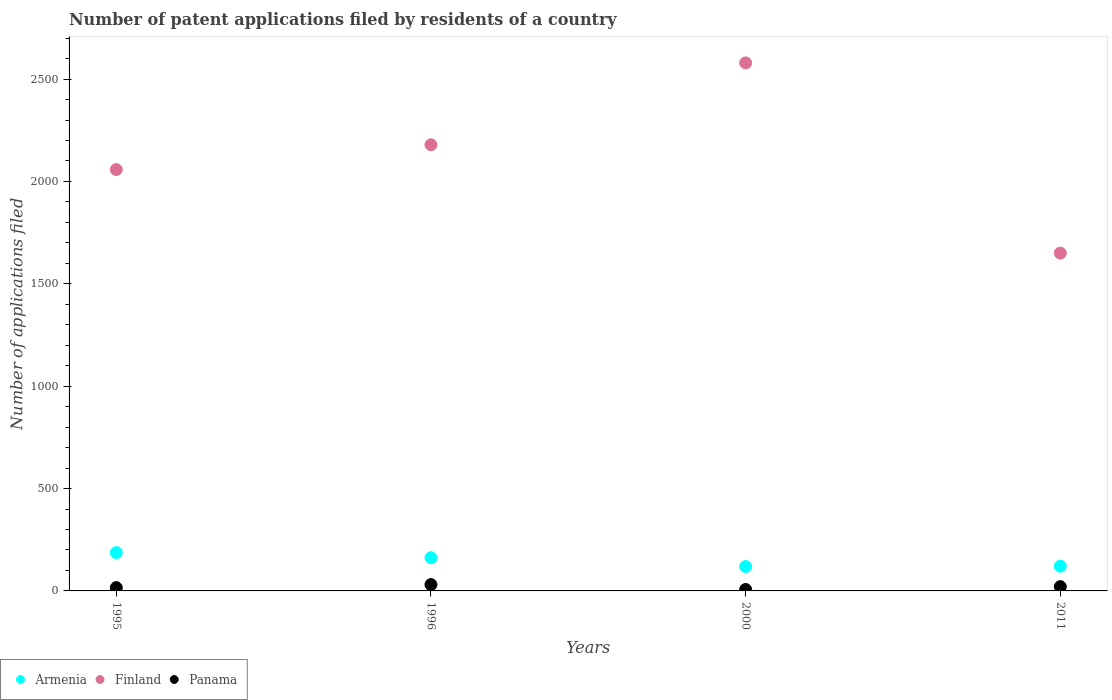How many different coloured dotlines are there?
Your answer should be very brief. 3. Is the number of dotlines equal to the number of legend labels?
Provide a succinct answer. Yes. Across all years, what is the maximum number of applications filed in Finland?
Offer a terse response. 2579. Across all years, what is the minimum number of applications filed in Armenia?
Make the answer very short. 119. In which year was the number of applications filed in Finland minimum?
Keep it short and to the point. 2011. What is the total number of applications filed in Panama in the graph?
Your answer should be very brief. 75. What is the difference between the number of applications filed in Armenia in 1996 and that in 2000?
Your answer should be very brief. 43. What is the difference between the number of applications filed in Panama in 2011 and the number of applications filed in Finland in 1995?
Make the answer very short. -2037. What is the average number of applications filed in Finland per year?
Your answer should be very brief. 2116.5. In the year 2000, what is the difference between the number of applications filed in Panama and number of applications filed in Armenia?
Your answer should be very brief. -112. What is the ratio of the number of applications filed in Finland in 1996 to that in 2000?
Your answer should be compact. 0.84. Is the number of applications filed in Panama in 2000 less than that in 2011?
Give a very brief answer. Yes. Is the difference between the number of applications filed in Panama in 1996 and 2011 greater than the difference between the number of applications filed in Armenia in 1996 and 2011?
Ensure brevity in your answer.  No. What is the difference between the highest and the lowest number of applications filed in Armenia?
Provide a succinct answer. 68. Is the number of applications filed in Armenia strictly greater than the number of applications filed in Panama over the years?
Keep it short and to the point. Yes. Is the number of applications filed in Armenia strictly less than the number of applications filed in Panama over the years?
Offer a terse response. No. How many dotlines are there?
Ensure brevity in your answer.  3. Are the values on the major ticks of Y-axis written in scientific E-notation?
Make the answer very short. No. Does the graph contain any zero values?
Offer a terse response. No. Where does the legend appear in the graph?
Ensure brevity in your answer.  Bottom left. How many legend labels are there?
Give a very brief answer. 3. How are the legend labels stacked?
Provide a short and direct response. Horizontal. What is the title of the graph?
Keep it short and to the point. Number of patent applications filed by residents of a country. What is the label or title of the Y-axis?
Your response must be concise. Number of applications filed. What is the Number of applications filed of Armenia in 1995?
Make the answer very short. 187. What is the Number of applications filed of Finland in 1995?
Keep it short and to the point. 2058. What is the Number of applications filed in Panama in 1995?
Provide a succinct answer. 16. What is the Number of applications filed of Armenia in 1996?
Offer a very short reply. 162. What is the Number of applications filed in Finland in 1996?
Your response must be concise. 2179. What is the Number of applications filed of Armenia in 2000?
Give a very brief answer. 119. What is the Number of applications filed of Finland in 2000?
Make the answer very short. 2579. What is the Number of applications filed in Armenia in 2011?
Offer a terse response. 121. What is the Number of applications filed in Finland in 2011?
Provide a succinct answer. 1650. What is the Number of applications filed of Panama in 2011?
Ensure brevity in your answer.  21. Across all years, what is the maximum Number of applications filed in Armenia?
Give a very brief answer. 187. Across all years, what is the maximum Number of applications filed in Finland?
Your answer should be very brief. 2579. Across all years, what is the minimum Number of applications filed of Armenia?
Offer a very short reply. 119. Across all years, what is the minimum Number of applications filed in Finland?
Ensure brevity in your answer.  1650. Across all years, what is the minimum Number of applications filed in Panama?
Your response must be concise. 7. What is the total Number of applications filed of Armenia in the graph?
Provide a short and direct response. 589. What is the total Number of applications filed of Finland in the graph?
Offer a terse response. 8466. What is the difference between the Number of applications filed of Armenia in 1995 and that in 1996?
Your answer should be very brief. 25. What is the difference between the Number of applications filed of Finland in 1995 and that in 1996?
Ensure brevity in your answer.  -121. What is the difference between the Number of applications filed of Armenia in 1995 and that in 2000?
Provide a succinct answer. 68. What is the difference between the Number of applications filed of Finland in 1995 and that in 2000?
Offer a terse response. -521. What is the difference between the Number of applications filed of Panama in 1995 and that in 2000?
Your answer should be very brief. 9. What is the difference between the Number of applications filed in Armenia in 1995 and that in 2011?
Provide a short and direct response. 66. What is the difference between the Number of applications filed in Finland in 1995 and that in 2011?
Ensure brevity in your answer.  408. What is the difference between the Number of applications filed in Panama in 1995 and that in 2011?
Your answer should be compact. -5. What is the difference between the Number of applications filed of Armenia in 1996 and that in 2000?
Provide a succinct answer. 43. What is the difference between the Number of applications filed of Finland in 1996 and that in 2000?
Offer a terse response. -400. What is the difference between the Number of applications filed in Panama in 1996 and that in 2000?
Ensure brevity in your answer.  24. What is the difference between the Number of applications filed in Armenia in 1996 and that in 2011?
Give a very brief answer. 41. What is the difference between the Number of applications filed of Finland in 1996 and that in 2011?
Give a very brief answer. 529. What is the difference between the Number of applications filed of Armenia in 2000 and that in 2011?
Offer a very short reply. -2. What is the difference between the Number of applications filed in Finland in 2000 and that in 2011?
Offer a terse response. 929. What is the difference between the Number of applications filed in Panama in 2000 and that in 2011?
Make the answer very short. -14. What is the difference between the Number of applications filed of Armenia in 1995 and the Number of applications filed of Finland in 1996?
Make the answer very short. -1992. What is the difference between the Number of applications filed of Armenia in 1995 and the Number of applications filed of Panama in 1996?
Offer a terse response. 156. What is the difference between the Number of applications filed of Finland in 1995 and the Number of applications filed of Panama in 1996?
Provide a short and direct response. 2027. What is the difference between the Number of applications filed in Armenia in 1995 and the Number of applications filed in Finland in 2000?
Give a very brief answer. -2392. What is the difference between the Number of applications filed of Armenia in 1995 and the Number of applications filed of Panama in 2000?
Provide a short and direct response. 180. What is the difference between the Number of applications filed of Finland in 1995 and the Number of applications filed of Panama in 2000?
Make the answer very short. 2051. What is the difference between the Number of applications filed in Armenia in 1995 and the Number of applications filed in Finland in 2011?
Your response must be concise. -1463. What is the difference between the Number of applications filed in Armenia in 1995 and the Number of applications filed in Panama in 2011?
Offer a terse response. 166. What is the difference between the Number of applications filed in Finland in 1995 and the Number of applications filed in Panama in 2011?
Make the answer very short. 2037. What is the difference between the Number of applications filed in Armenia in 1996 and the Number of applications filed in Finland in 2000?
Your answer should be very brief. -2417. What is the difference between the Number of applications filed of Armenia in 1996 and the Number of applications filed of Panama in 2000?
Offer a very short reply. 155. What is the difference between the Number of applications filed in Finland in 1996 and the Number of applications filed in Panama in 2000?
Your answer should be compact. 2172. What is the difference between the Number of applications filed of Armenia in 1996 and the Number of applications filed of Finland in 2011?
Your answer should be compact. -1488. What is the difference between the Number of applications filed in Armenia in 1996 and the Number of applications filed in Panama in 2011?
Give a very brief answer. 141. What is the difference between the Number of applications filed in Finland in 1996 and the Number of applications filed in Panama in 2011?
Your answer should be compact. 2158. What is the difference between the Number of applications filed in Armenia in 2000 and the Number of applications filed in Finland in 2011?
Your response must be concise. -1531. What is the difference between the Number of applications filed in Finland in 2000 and the Number of applications filed in Panama in 2011?
Your answer should be very brief. 2558. What is the average Number of applications filed of Armenia per year?
Your response must be concise. 147.25. What is the average Number of applications filed of Finland per year?
Your answer should be very brief. 2116.5. What is the average Number of applications filed in Panama per year?
Keep it short and to the point. 18.75. In the year 1995, what is the difference between the Number of applications filed in Armenia and Number of applications filed in Finland?
Provide a short and direct response. -1871. In the year 1995, what is the difference between the Number of applications filed in Armenia and Number of applications filed in Panama?
Provide a succinct answer. 171. In the year 1995, what is the difference between the Number of applications filed in Finland and Number of applications filed in Panama?
Provide a succinct answer. 2042. In the year 1996, what is the difference between the Number of applications filed of Armenia and Number of applications filed of Finland?
Offer a terse response. -2017. In the year 1996, what is the difference between the Number of applications filed of Armenia and Number of applications filed of Panama?
Make the answer very short. 131. In the year 1996, what is the difference between the Number of applications filed of Finland and Number of applications filed of Panama?
Offer a terse response. 2148. In the year 2000, what is the difference between the Number of applications filed of Armenia and Number of applications filed of Finland?
Offer a terse response. -2460. In the year 2000, what is the difference between the Number of applications filed in Armenia and Number of applications filed in Panama?
Offer a very short reply. 112. In the year 2000, what is the difference between the Number of applications filed of Finland and Number of applications filed of Panama?
Provide a short and direct response. 2572. In the year 2011, what is the difference between the Number of applications filed of Armenia and Number of applications filed of Finland?
Your answer should be very brief. -1529. In the year 2011, what is the difference between the Number of applications filed in Armenia and Number of applications filed in Panama?
Make the answer very short. 100. In the year 2011, what is the difference between the Number of applications filed of Finland and Number of applications filed of Panama?
Provide a succinct answer. 1629. What is the ratio of the Number of applications filed in Armenia in 1995 to that in 1996?
Your response must be concise. 1.15. What is the ratio of the Number of applications filed of Finland in 1995 to that in 1996?
Offer a very short reply. 0.94. What is the ratio of the Number of applications filed of Panama in 1995 to that in 1996?
Offer a very short reply. 0.52. What is the ratio of the Number of applications filed of Armenia in 1995 to that in 2000?
Your answer should be compact. 1.57. What is the ratio of the Number of applications filed of Finland in 1995 to that in 2000?
Offer a very short reply. 0.8. What is the ratio of the Number of applications filed of Panama in 1995 to that in 2000?
Ensure brevity in your answer.  2.29. What is the ratio of the Number of applications filed in Armenia in 1995 to that in 2011?
Keep it short and to the point. 1.55. What is the ratio of the Number of applications filed in Finland in 1995 to that in 2011?
Provide a short and direct response. 1.25. What is the ratio of the Number of applications filed of Panama in 1995 to that in 2011?
Provide a succinct answer. 0.76. What is the ratio of the Number of applications filed of Armenia in 1996 to that in 2000?
Offer a terse response. 1.36. What is the ratio of the Number of applications filed of Finland in 1996 to that in 2000?
Ensure brevity in your answer.  0.84. What is the ratio of the Number of applications filed in Panama in 1996 to that in 2000?
Offer a terse response. 4.43. What is the ratio of the Number of applications filed of Armenia in 1996 to that in 2011?
Your answer should be very brief. 1.34. What is the ratio of the Number of applications filed of Finland in 1996 to that in 2011?
Your answer should be compact. 1.32. What is the ratio of the Number of applications filed in Panama in 1996 to that in 2011?
Your response must be concise. 1.48. What is the ratio of the Number of applications filed of Armenia in 2000 to that in 2011?
Your answer should be compact. 0.98. What is the ratio of the Number of applications filed in Finland in 2000 to that in 2011?
Provide a succinct answer. 1.56. What is the ratio of the Number of applications filed of Panama in 2000 to that in 2011?
Offer a very short reply. 0.33. What is the difference between the highest and the lowest Number of applications filed of Armenia?
Your response must be concise. 68. What is the difference between the highest and the lowest Number of applications filed in Finland?
Offer a terse response. 929. What is the difference between the highest and the lowest Number of applications filed of Panama?
Make the answer very short. 24. 